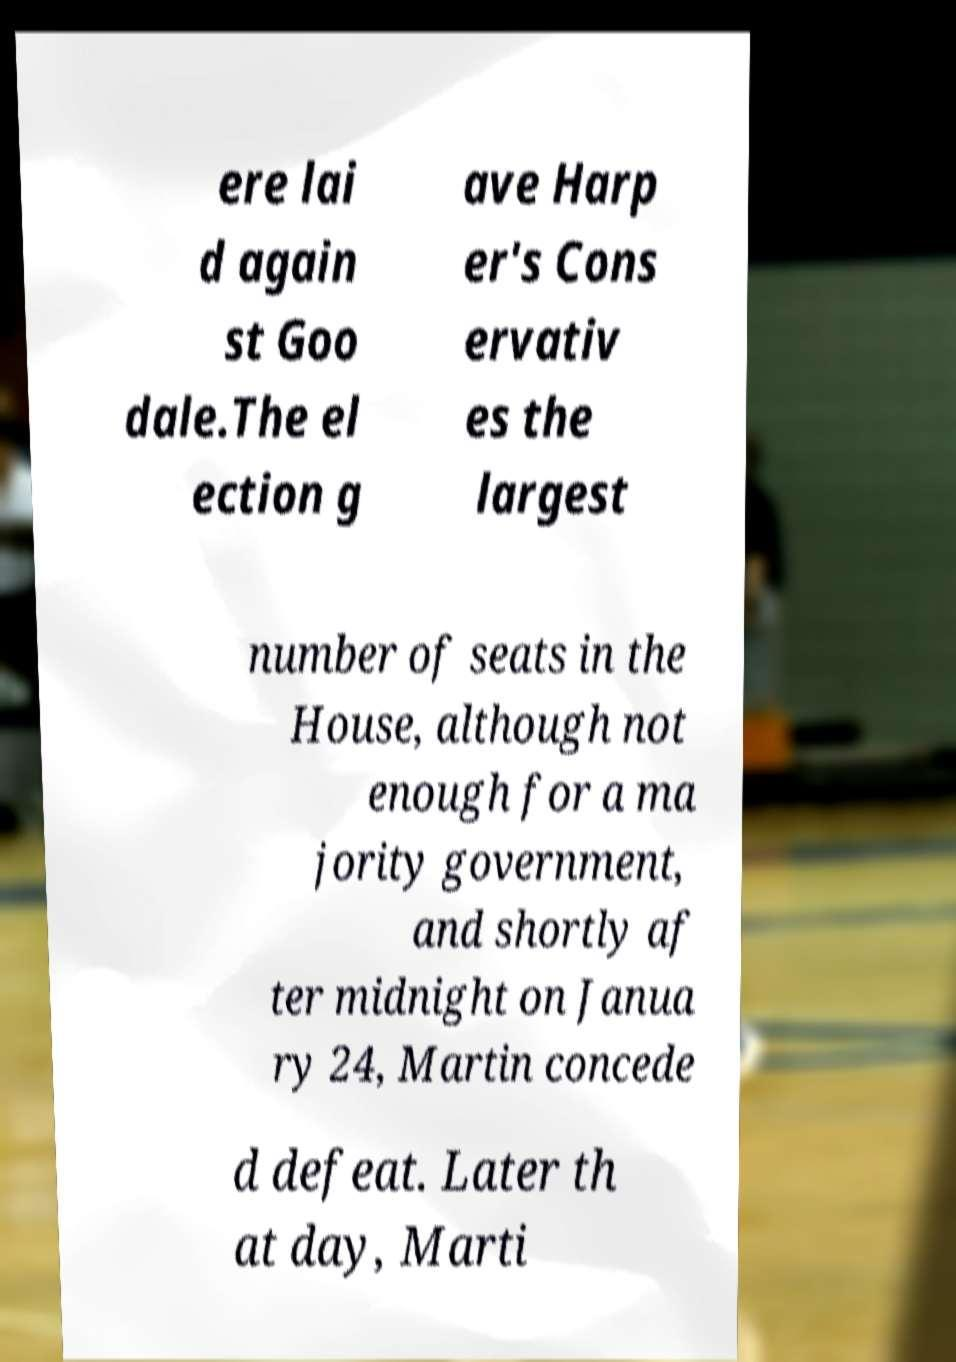There's text embedded in this image that I need extracted. Can you transcribe it verbatim? ere lai d again st Goo dale.The el ection g ave Harp er's Cons ervativ es the largest number of seats in the House, although not enough for a ma jority government, and shortly af ter midnight on Janua ry 24, Martin concede d defeat. Later th at day, Marti 